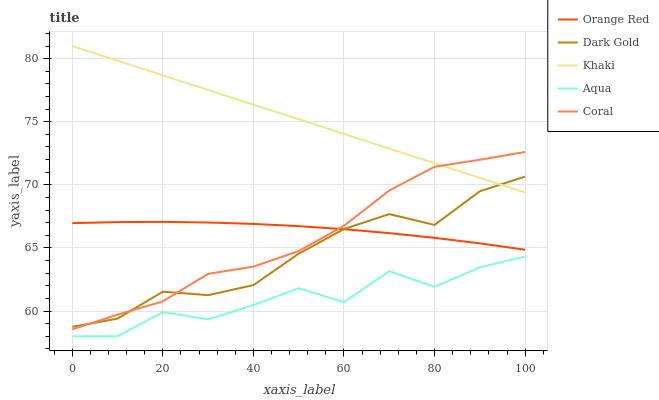Does Aqua have the minimum area under the curve?
Answer yes or no. Yes. Does Khaki have the maximum area under the curve?
Answer yes or no. Yes. Does Khaki have the minimum area under the curve?
Answer yes or no. No. Does Aqua have the maximum area under the curve?
Answer yes or no. No. Is Khaki the smoothest?
Answer yes or no. Yes. Is Aqua the roughest?
Answer yes or no. Yes. Is Aqua the smoothest?
Answer yes or no. No. Is Khaki the roughest?
Answer yes or no. No. Does Aqua have the lowest value?
Answer yes or no. Yes. Does Khaki have the lowest value?
Answer yes or no. No. Does Khaki have the highest value?
Answer yes or no. Yes. Does Aqua have the highest value?
Answer yes or no. No. Is Aqua less than Coral?
Answer yes or no. Yes. Is Khaki greater than Aqua?
Answer yes or no. Yes. Does Dark Gold intersect Orange Red?
Answer yes or no. Yes. Is Dark Gold less than Orange Red?
Answer yes or no. No. Is Dark Gold greater than Orange Red?
Answer yes or no. No. Does Aqua intersect Coral?
Answer yes or no. No. 